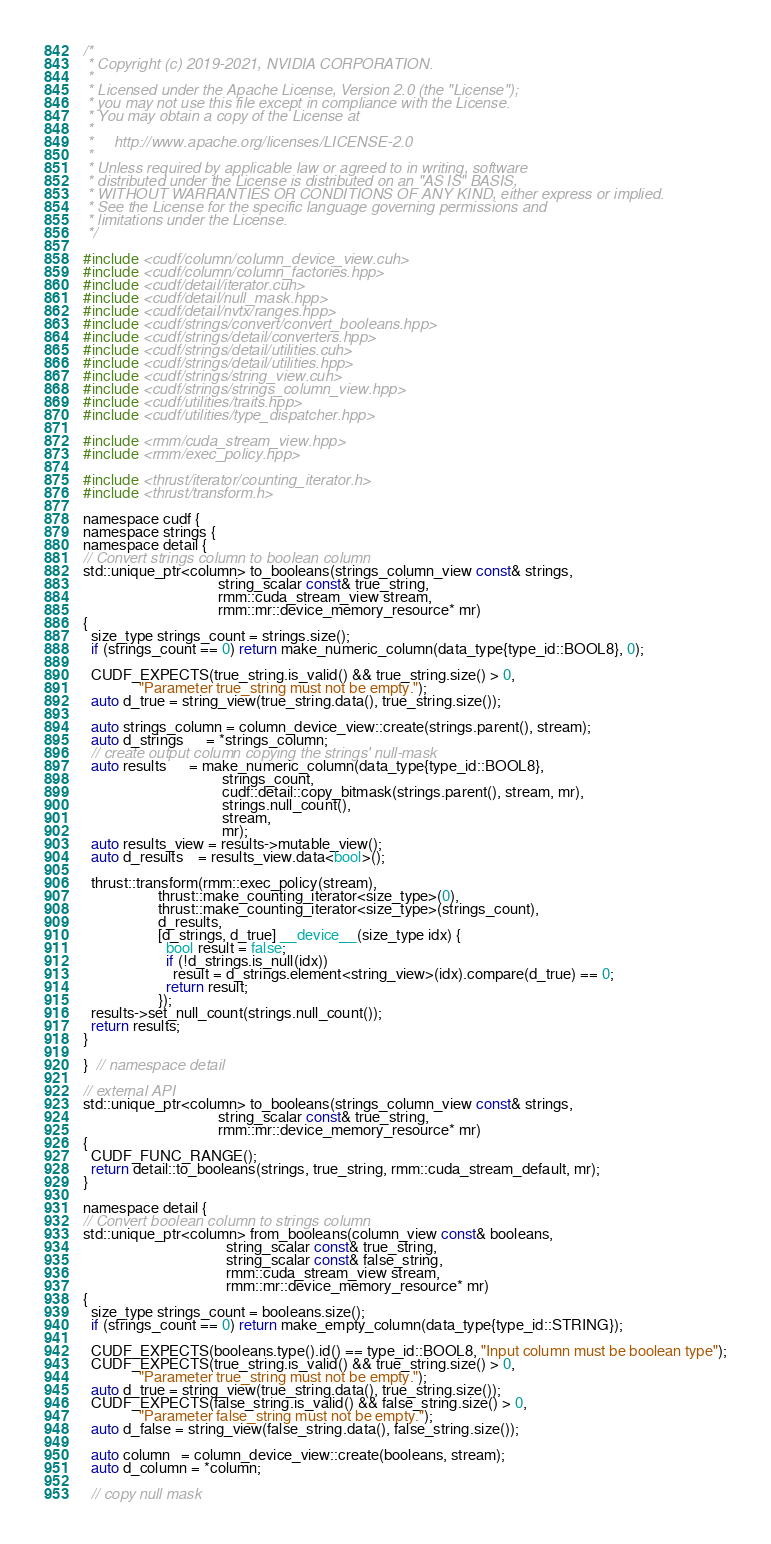<code> <loc_0><loc_0><loc_500><loc_500><_Cuda_>/*
 * Copyright (c) 2019-2021, NVIDIA CORPORATION.
 *
 * Licensed under the Apache License, Version 2.0 (the "License");
 * you may not use this file except in compliance with the License.
 * You may obtain a copy of the License at
 *
 *     http://www.apache.org/licenses/LICENSE-2.0
 *
 * Unless required by applicable law or agreed to in writing, software
 * distributed under the License is distributed on an "AS IS" BASIS,
 * WITHOUT WARRANTIES OR CONDITIONS OF ANY KIND, either express or implied.
 * See the License for the specific language governing permissions and
 * limitations under the License.
 */

#include <cudf/column/column_device_view.cuh>
#include <cudf/column/column_factories.hpp>
#include <cudf/detail/iterator.cuh>
#include <cudf/detail/null_mask.hpp>
#include <cudf/detail/nvtx/ranges.hpp>
#include <cudf/strings/convert/convert_booleans.hpp>
#include <cudf/strings/detail/converters.hpp>
#include <cudf/strings/detail/utilities.cuh>
#include <cudf/strings/detail/utilities.hpp>
#include <cudf/strings/string_view.cuh>
#include <cudf/strings/strings_column_view.hpp>
#include <cudf/utilities/traits.hpp>
#include <cudf/utilities/type_dispatcher.hpp>

#include <rmm/cuda_stream_view.hpp>
#include <rmm/exec_policy.hpp>

#include <thrust/iterator/counting_iterator.h>
#include <thrust/transform.h>

namespace cudf {
namespace strings {
namespace detail {
// Convert strings column to boolean column
std::unique_ptr<column> to_booleans(strings_column_view const& strings,
                                    string_scalar const& true_string,
                                    rmm::cuda_stream_view stream,
                                    rmm::mr::device_memory_resource* mr)
{
  size_type strings_count = strings.size();
  if (strings_count == 0) return make_numeric_column(data_type{type_id::BOOL8}, 0);

  CUDF_EXPECTS(true_string.is_valid() && true_string.size() > 0,
               "Parameter true_string must not be empty.");
  auto d_true = string_view(true_string.data(), true_string.size());

  auto strings_column = column_device_view::create(strings.parent(), stream);
  auto d_strings      = *strings_column;
  // create output column copying the strings' null-mask
  auto results      = make_numeric_column(data_type{type_id::BOOL8},
                                     strings_count,
                                     cudf::detail::copy_bitmask(strings.parent(), stream, mr),
                                     strings.null_count(),
                                     stream,
                                     mr);
  auto results_view = results->mutable_view();
  auto d_results    = results_view.data<bool>();

  thrust::transform(rmm::exec_policy(stream),
                    thrust::make_counting_iterator<size_type>(0),
                    thrust::make_counting_iterator<size_type>(strings_count),
                    d_results,
                    [d_strings, d_true] __device__(size_type idx) {
                      bool result = false;
                      if (!d_strings.is_null(idx))
                        result = d_strings.element<string_view>(idx).compare(d_true) == 0;
                      return result;
                    });
  results->set_null_count(strings.null_count());
  return results;
}

}  // namespace detail

// external API
std::unique_ptr<column> to_booleans(strings_column_view const& strings,
                                    string_scalar const& true_string,
                                    rmm::mr::device_memory_resource* mr)
{
  CUDF_FUNC_RANGE();
  return detail::to_booleans(strings, true_string, rmm::cuda_stream_default, mr);
}

namespace detail {
// Convert boolean column to strings column
std::unique_ptr<column> from_booleans(column_view const& booleans,
                                      string_scalar const& true_string,
                                      string_scalar const& false_string,
                                      rmm::cuda_stream_view stream,
                                      rmm::mr::device_memory_resource* mr)
{
  size_type strings_count = booleans.size();
  if (strings_count == 0) return make_empty_column(data_type{type_id::STRING});

  CUDF_EXPECTS(booleans.type().id() == type_id::BOOL8, "Input column must be boolean type");
  CUDF_EXPECTS(true_string.is_valid() && true_string.size() > 0,
               "Parameter true_string must not be empty.");
  auto d_true = string_view(true_string.data(), true_string.size());
  CUDF_EXPECTS(false_string.is_valid() && false_string.size() > 0,
               "Parameter false_string must not be empty.");
  auto d_false = string_view(false_string.data(), false_string.size());

  auto column   = column_device_view::create(booleans, stream);
  auto d_column = *column;

  // copy null mask</code> 